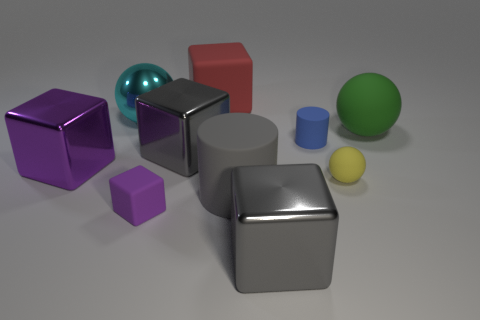The thing that is the same color as the small block is what shape?
Give a very brief answer. Cube. What number of gray matte cylinders are the same size as the green object?
Your response must be concise. 1. Is there a blue cylinder that is behind the large matte thing that is left of the big gray rubber object?
Offer a very short reply. No. What number of objects are large cyan metal blocks or yellow rubber spheres?
Your answer should be compact. 1. There is a cylinder to the right of the cylinder that is in front of the purple cube left of the cyan thing; what color is it?
Your answer should be compact. Blue. Is there any other thing that is the same color as the tiny cylinder?
Provide a short and direct response. No. Is the yellow rubber sphere the same size as the red object?
Provide a short and direct response. No. How many things are either rubber things in front of the shiny ball or small matte things in front of the big purple shiny cube?
Your answer should be compact. 5. There is a small object left of the large rubber thing that is behind the cyan object; what is it made of?
Your response must be concise. Rubber. What number of other things are there of the same material as the large green ball
Offer a terse response. 5. 